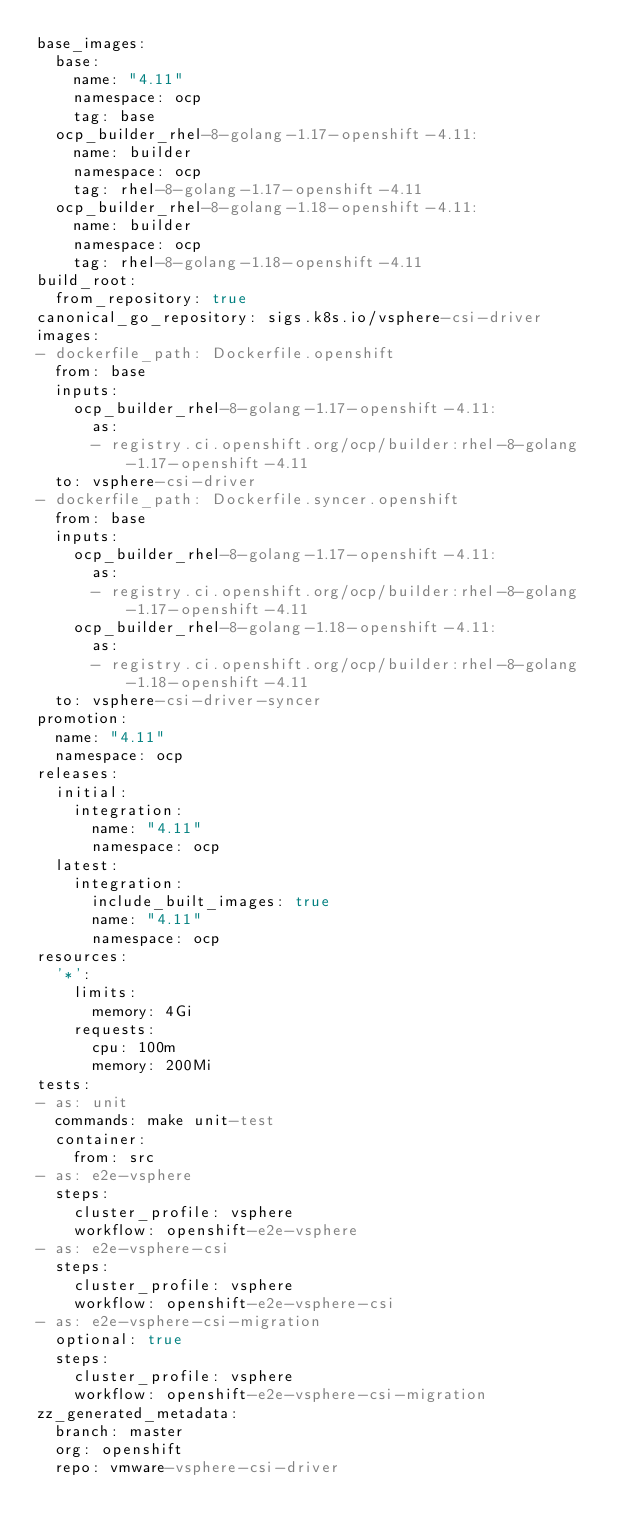Convert code to text. <code><loc_0><loc_0><loc_500><loc_500><_YAML_>base_images:
  base:
    name: "4.11"
    namespace: ocp
    tag: base
  ocp_builder_rhel-8-golang-1.17-openshift-4.11:
    name: builder
    namespace: ocp
    tag: rhel-8-golang-1.17-openshift-4.11
  ocp_builder_rhel-8-golang-1.18-openshift-4.11:
    name: builder
    namespace: ocp
    tag: rhel-8-golang-1.18-openshift-4.11
build_root:
  from_repository: true
canonical_go_repository: sigs.k8s.io/vsphere-csi-driver
images:
- dockerfile_path: Dockerfile.openshift
  from: base
  inputs:
    ocp_builder_rhel-8-golang-1.17-openshift-4.11:
      as:
      - registry.ci.openshift.org/ocp/builder:rhel-8-golang-1.17-openshift-4.11
  to: vsphere-csi-driver
- dockerfile_path: Dockerfile.syncer.openshift
  from: base
  inputs:
    ocp_builder_rhel-8-golang-1.17-openshift-4.11:
      as:
      - registry.ci.openshift.org/ocp/builder:rhel-8-golang-1.17-openshift-4.11
    ocp_builder_rhel-8-golang-1.18-openshift-4.11:
      as:
      - registry.ci.openshift.org/ocp/builder:rhel-8-golang-1.18-openshift-4.11
  to: vsphere-csi-driver-syncer
promotion:
  name: "4.11"
  namespace: ocp
releases:
  initial:
    integration:
      name: "4.11"
      namespace: ocp
  latest:
    integration:
      include_built_images: true
      name: "4.11"
      namespace: ocp
resources:
  '*':
    limits:
      memory: 4Gi
    requests:
      cpu: 100m
      memory: 200Mi
tests:
- as: unit
  commands: make unit-test
  container:
    from: src
- as: e2e-vsphere
  steps:
    cluster_profile: vsphere
    workflow: openshift-e2e-vsphere
- as: e2e-vsphere-csi
  steps:
    cluster_profile: vsphere
    workflow: openshift-e2e-vsphere-csi
- as: e2e-vsphere-csi-migration
  optional: true
  steps:
    cluster_profile: vsphere
    workflow: openshift-e2e-vsphere-csi-migration
zz_generated_metadata:
  branch: master
  org: openshift
  repo: vmware-vsphere-csi-driver
</code> 